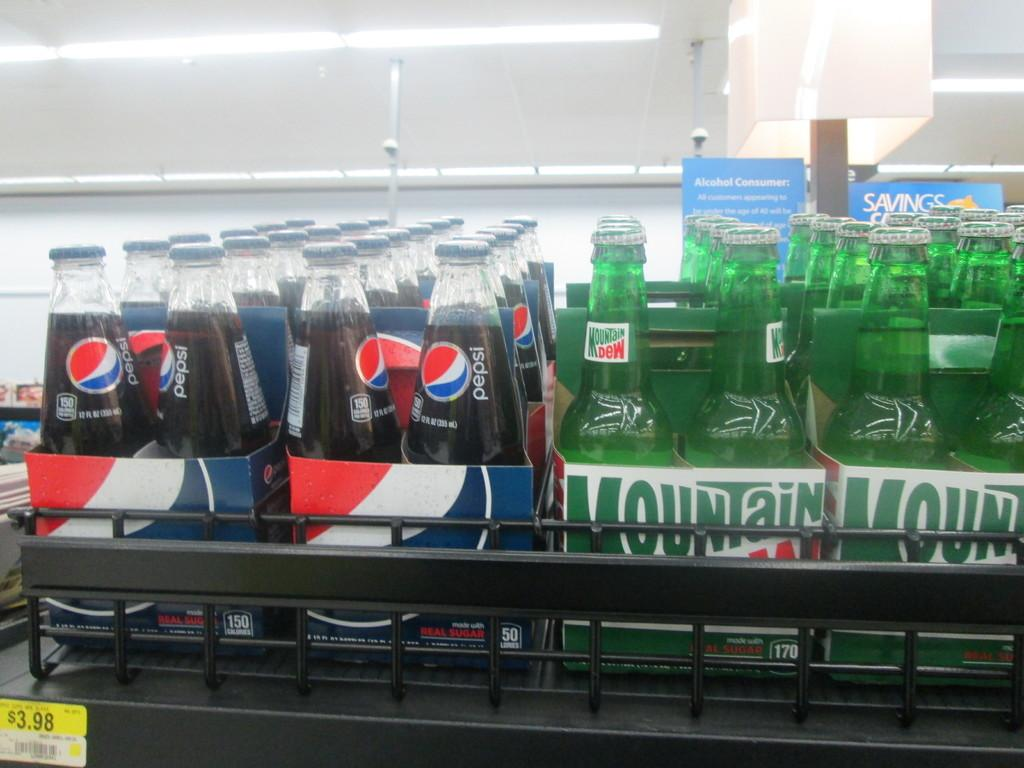<image>
Render a clear and concise summary of the photo. Boxes of pepsi sit next to boxes of mountain dew on a store shelf. 